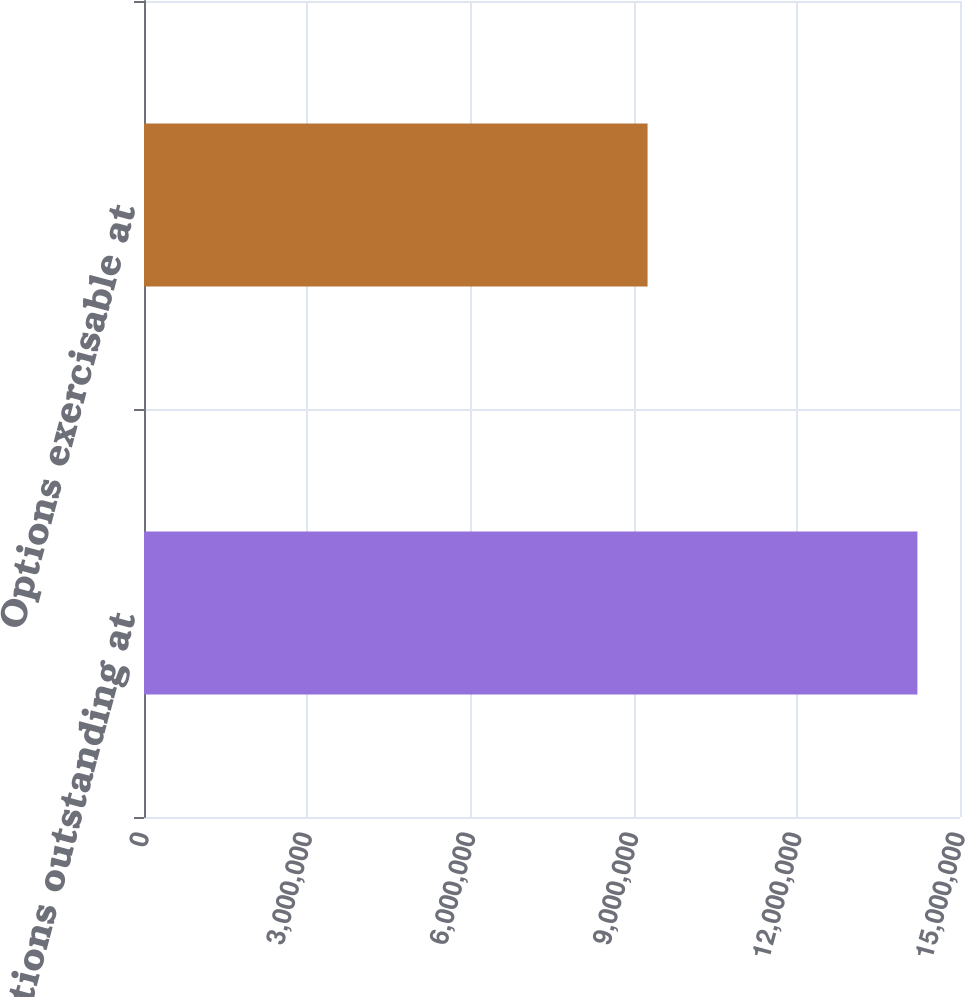Convert chart. <chart><loc_0><loc_0><loc_500><loc_500><bar_chart><fcel>Options outstanding at<fcel>Options exercisable at<nl><fcel>1.42171e+07<fcel>9.25682e+06<nl></chart> 